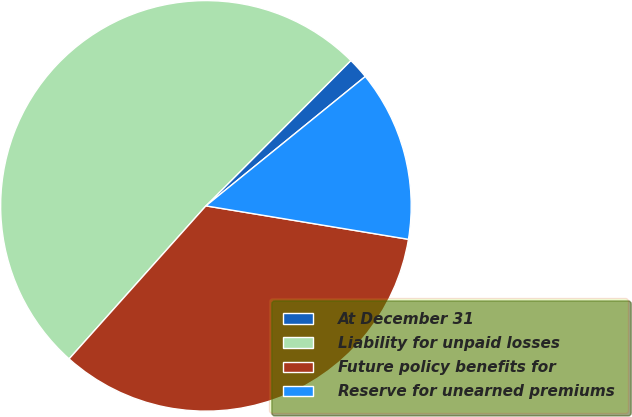<chart> <loc_0><loc_0><loc_500><loc_500><pie_chart><fcel>At December 31<fcel>Liability for unpaid losses<fcel>Future policy benefits for<fcel>Reserve for unearned premiums<nl><fcel>1.67%<fcel>50.87%<fcel>34.01%<fcel>13.46%<nl></chart> 